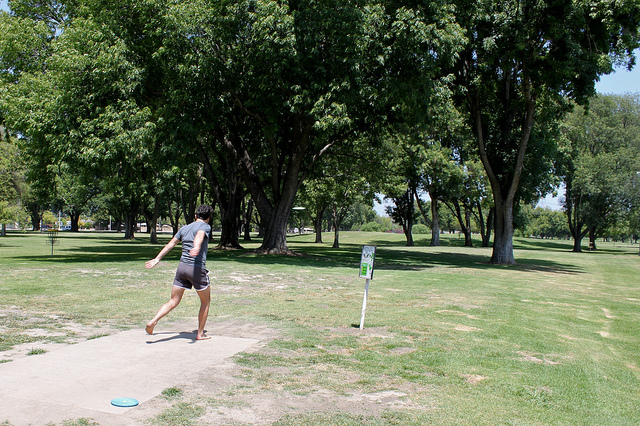<image>What does this park offer for frisbee players? I don't know what the park offers for frisbee players. It could be frisbee golf or just a lot of space. What does this park offer for frisbee players? I am not sure what this park offers for frisbee players. It can be sand, frisbee golf, frisbee course, or lots of green space. 